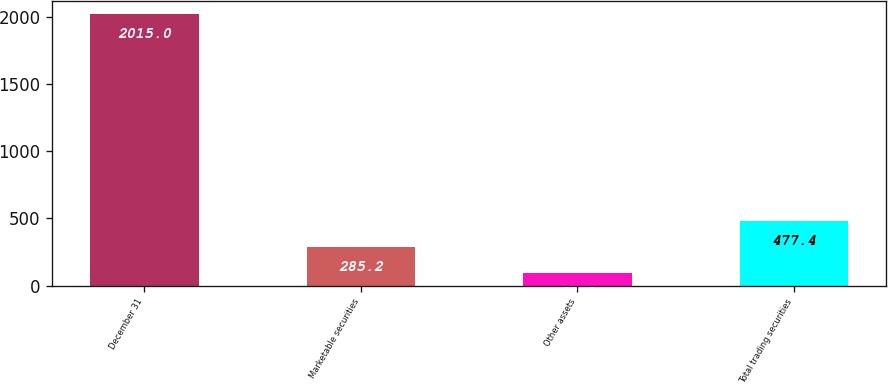<chart> <loc_0><loc_0><loc_500><loc_500><bar_chart><fcel>December 31<fcel>Marketable securities<fcel>Other assets<fcel>Total trading securities<nl><fcel>2015<fcel>285.2<fcel>93<fcel>477.4<nl></chart> 